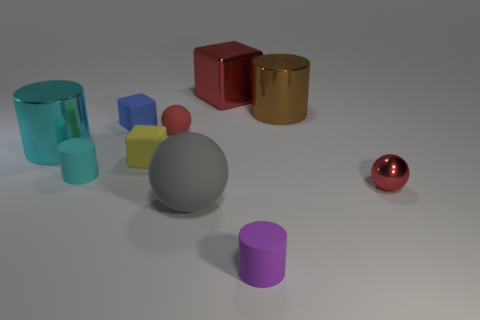What is the material of the cyan cylinder that is the same size as the red matte thing?
Your answer should be compact. Rubber. The shiny object that is both behind the small red matte ball and to the right of the purple matte object has what shape?
Your answer should be very brief. Cylinder. There is a large shiny cylinder in front of the brown cylinder; what color is it?
Your answer should be compact. Cyan. There is a cylinder that is behind the gray ball and to the right of the big red cube; what is its size?
Keep it short and to the point. Large. Do the tiny blue object and the big cylinder that is in front of the small blue matte block have the same material?
Ensure brevity in your answer.  No. How many small yellow matte objects are the same shape as the big rubber thing?
Provide a short and direct response. 0. What material is the big block that is the same color as the tiny shiny object?
Your answer should be very brief. Metal. What number of small purple metallic cylinders are there?
Provide a succinct answer. 0. There is a tiny blue rubber thing; is its shape the same as the red thing that is right of the small purple matte cylinder?
Your answer should be compact. No. How many objects are either cyan blocks or big objects that are in front of the small red metallic ball?
Your response must be concise. 1. 